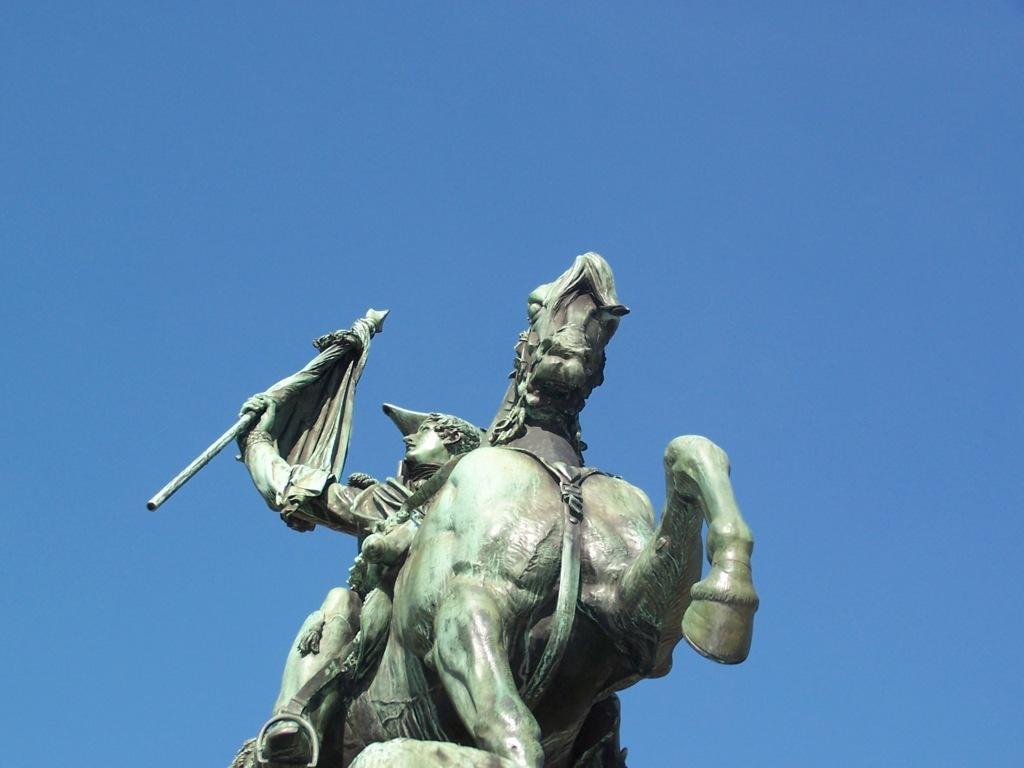What is the main subject of the image? The main subject of the image is a statue of a person sitting on a horse and holding a flag with his hand. What can be seen in the background of the image? The background of the image includes the sky. How many cats are sitting on the horse with the person in the image? There are no cats present in the image; it features a statue of a person sitting on a horse and holding a flag. What type of yam is being used as a prop in the image? There is no yam present in the image; it features a statue of a person sitting on a horse and holding a flag. 